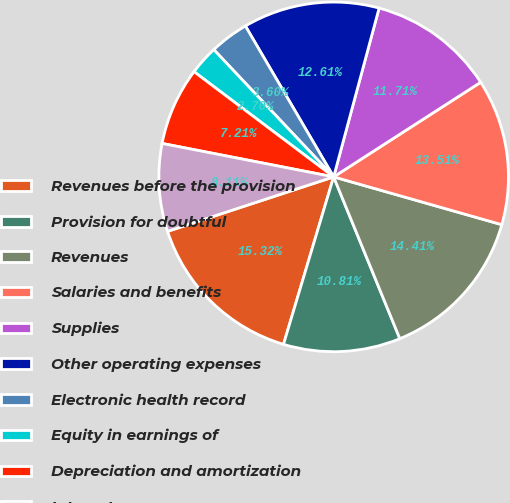<chart> <loc_0><loc_0><loc_500><loc_500><pie_chart><fcel>Revenues before the provision<fcel>Provision for doubtful<fcel>Revenues<fcel>Salaries and benefits<fcel>Supplies<fcel>Other operating expenses<fcel>Electronic health record<fcel>Equity in earnings of<fcel>Depreciation and amortization<fcel>Interest expense<nl><fcel>15.32%<fcel>10.81%<fcel>14.41%<fcel>13.51%<fcel>11.71%<fcel>12.61%<fcel>3.6%<fcel>2.7%<fcel>7.21%<fcel>8.11%<nl></chart> 